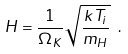<formula> <loc_0><loc_0><loc_500><loc_500>H = \frac { 1 } { \Omega _ { K } } \sqrt { \frac { k T _ { i } } { m _ { H } } } \ .</formula> 